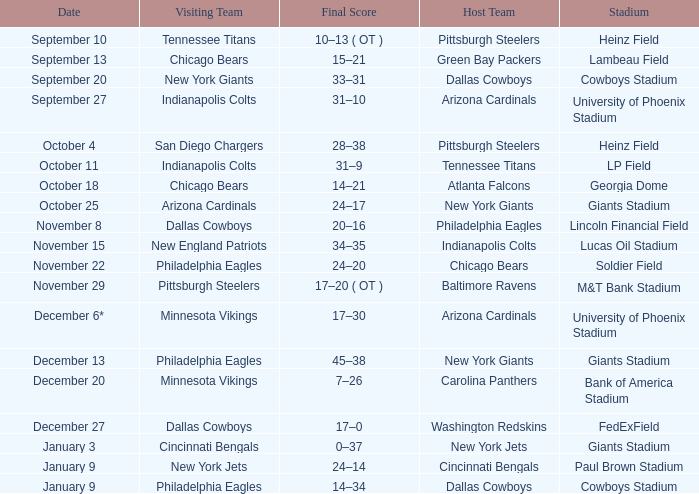I want to know the stadium for tennessee titans visiting Heinz Field. 